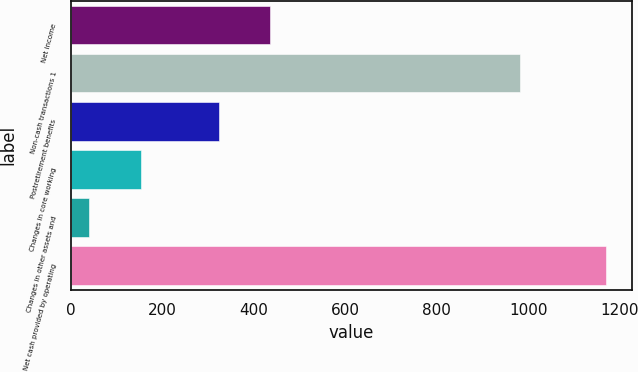Convert chart. <chart><loc_0><loc_0><loc_500><loc_500><bar_chart><fcel>Net income<fcel>Non-cash transactions 1<fcel>Postretirement benefits<fcel>Changes in core working<fcel>Changes in other assets and<fcel>Net cash provided by operating<nl><fcel>435.8<fcel>981<fcel>323<fcel>153.8<fcel>41<fcel>1169<nl></chart> 